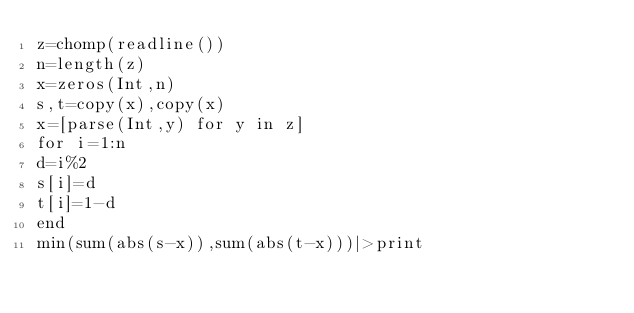<code> <loc_0><loc_0><loc_500><loc_500><_Julia_>z=chomp(readline())
n=length(z)
x=zeros(Int,n)
s,t=copy(x),copy(x)
x=[parse(Int,y) for y in z]
for i=1:n
d=i%2
s[i]=d
t[i]=1-d
end
min(sum(abs(s-x)),sum(abs(t-x)))|>print</code> 